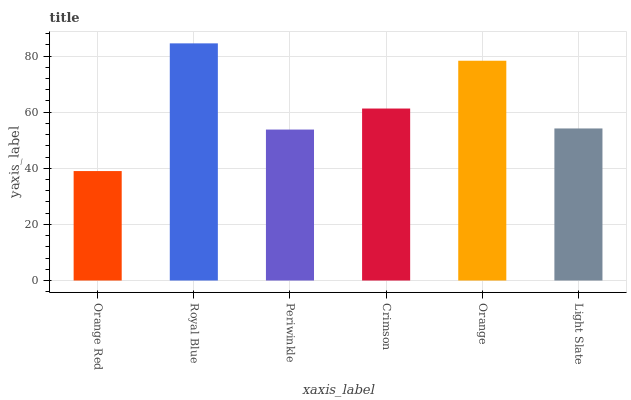Is Orange Red the minimum?
Answer yes or no. Yes. Is Royal Blue the maximum?
Answer yes or no. Yes. Is Periwinkle the minimum?
Answer yes or no. No. Is Periwinkle the maximum?
Answer yes or no. No. Is Royal Blue greater than Periwinkle?
Answer yes or no. Yes. Is Periwinkle less than Royal Blue?
Answer yes or no. Yes. Is Periwinkle greater than Royal Blue?
Answer yes or no. No. Is Royal Blue less than Periwinkle?
Answer yes or no. No. Is Crimson the high median?
Answer yes or no. Yes. Is Light Slate the low median?
Answer yes or no. Yes. Is Periwinkle the high median?
Answer yes or no. No. Is Periwinkle the low median?
Answer yes or no. No. 